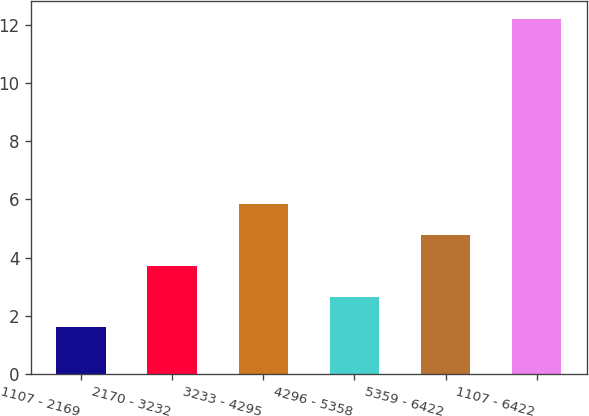Convert chart. <chart><loc_0><loc_0><loc_500><loc_500><bar_chart><fcel>1107 - 2169<fcel>2170 - 3232<fcel>3233 - 4295<fcel>4296 - 5358<fcel>5359 - 6422<fcel>1107 - 6422<nl><fcel>1.6<fcel>3.72<fcel>5.84<fcel>2.66<fcel>4.78<fcel>12.2<nl></chart> 